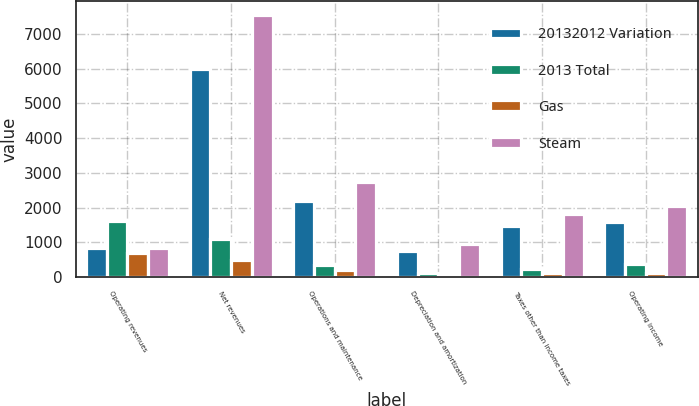Convert chart. <chart><loc_0><loc_0><loc_500><loc_500><stacked_bar_chart><ecel><fcel>Operating revenues<fcel>Net revenues<fcel>Operations and maintenance<fcel>Depreciation and amortization<fcel>Taxes other than income taxes<fcel>Operating income<nl><fcel>20132012 Variation<fcel>847.5<fcel>5983<fcel>2180<fcel>749<fcel>1459<fcel>1595<nl><fcel>2013 Total<fcel>1616<fcel>1084<fcel>351<fcel>130<fcel>241<fcel>362<nl><fcel>Gas<fcel>683<fcel>490<fcel>204<fcel>67<fcel>116<fcel>103<nl><fcel>Steam<fcel>847.5<fcel>7557<fcel>2735<fcel>946<fcel>1816<fcel>2060<nl></chart> 